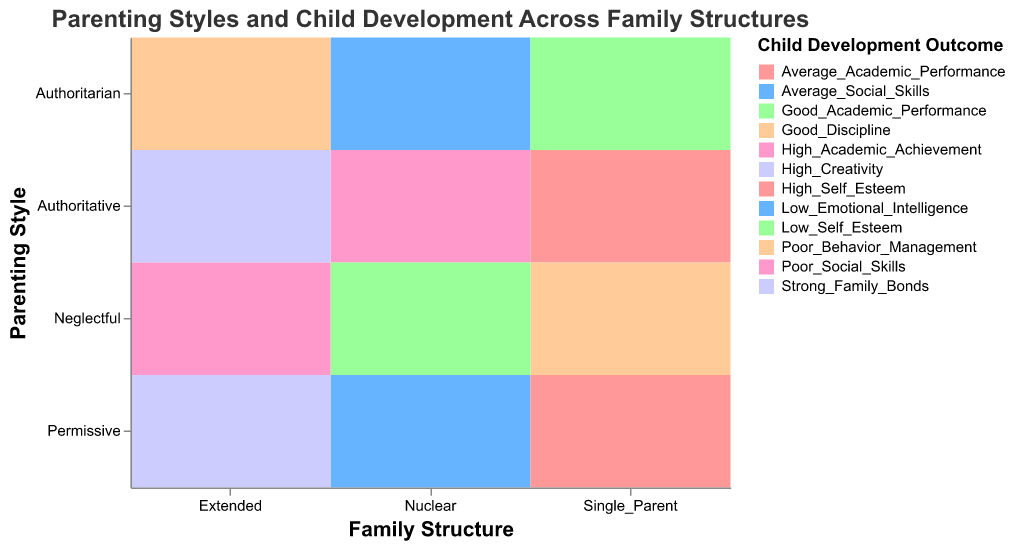What is the title of the figure? The title is often found at the top of the figure and summarizes the content it depicts.
Answer: Parenting Styles and Child Development Across Family Structures How many different child development outcomes are displayed in the figure? Count the unique child development outcomes represented by different colors in the legend.
Answer: 6 Which family structure has the highest variety of parenting styles? Observe the family structure categories on the x-axis and check which one shows the most different parenting styles on the y-axis.
Answer: Extended In the nuclear family structure, which parenting style is associated with high academic achievement? Look at the section of the plot corresponding to the nuclear family structure and identify the parenting style linked to high academic achievement by its filled color.
Answer: Authoritative How is creativity reflected across different family structures? Compare the representation of high creativity (color associated with this outcome) across the family structure categories on the x-axis to identify where it appears.
Answer: Only in extended families Which family structure shows a parenting style associated with good academic performance under a single parent setting? Locate the single-parent category on the x-axis and identify which parenting style is linked to good academic performance by color coding.
Answer: Authoritarian What is the most common child development outcome for authoritative parenting across all family structures? Check the authoritative parenting style rows across different family structures and record the most frequently occurring child development outcomes.
Answer: High academic achievement / High self-esteem / Strong family bonds Are there any family structures where neglectful parenting does not result in poor outcomes? Inspect all cases of neglectful parenting across the family structures and check if any child development outcomes aren't poor. If found, identify which structure.
Answer: No Compare the outcomes of permissive parenting in nuclear and extended family structures. Find the permissive parenting rows in both nuclear and extended family structures and compare the child development outcomes.
Answer: Average social skills / high creativity What differences are observed in child development outcomes between authoritative and authoritarian parenting in extended families? Look at the extended family structure on the x-axis and compare the color patterns corresponding to authoritative and authoritarian parenting styles.
Answer: Strong family bonds vs. good discipline 